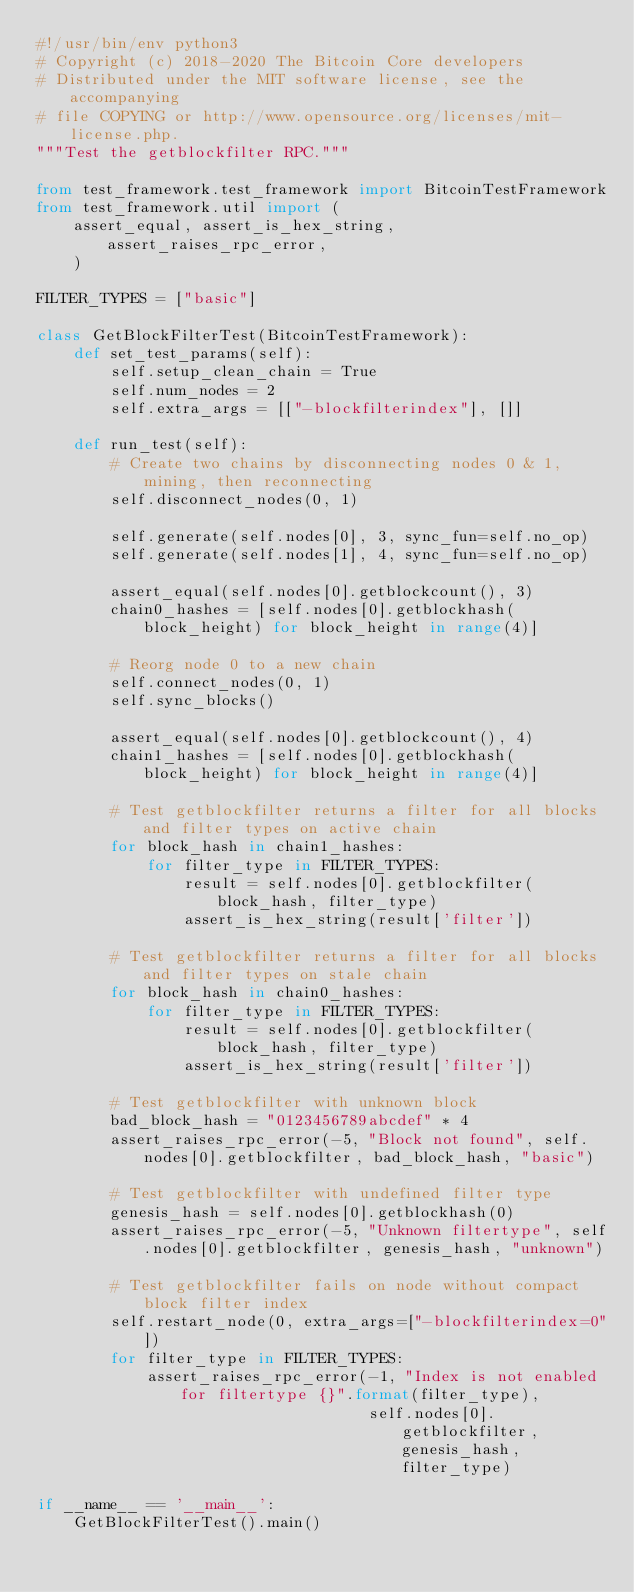<code> <loc_0><loc_0><loc_500><loc_500><_Python_>#!/usr/bin/env python3
# Copyright (c) 2018-2020 The Bitcoin Core developers
# Distributed under the MIT software license, see the accompanying
# file COPYING or http://www.opensource.org/licenses/mit-license.php.
"""Test the getblockfilter RPC."""

from test_framework.test_framework import BitcoinTestFramework
from test_framework.util import (
    assert_equal, assert_is_hex_string, assert_raises_rpc_error,
    )

FILTER_TYPES = ["basic"]

class GetBlockFilterTest(BitcoinTestFramework):
    def set_test_params(self):
        self.setup_clean_chain = True
        self.num_nodes = 2
        self.extra_args = [["-blockfilterindex"], []]

    def run_test(self):
        # Create two chains by disconnecting nodes 0 & 1, mining, then reconnecting
        self.disconnect_nodes(0, 1)

        self.generate(self.nodes[0], 3, sync_fun=self.no_op)
        self.generate(self.nodes[1], 4, sync_fun=self.no_op)

        assert_equal(self.nodes[0].getblockcount(), 3)
        chain0_hashes = [self.nodes[0].getblockhash(block_height) for block_height in range(4)]

        # Reorg node 0 to a new chain
        self.connect_nodes(0, 1)
        self.sync_blocks()

        assert_equal(self.nodes[0].getblockcount(), 4)
        chain1_hashes = [self.nodes[0].getblockhash(block_height) for block_height in range(4)]

        # Test getblockfilter returns a filter for all blocks and filter types on active chain
        for block_hash in chain1_hashes:
            for filter_type in FILTER_TYPES:
                result = self.nodes[0].getblockfilter(block_hash, filter_type)
                assert_is_hex_string(result['filter'])

        # Test getblockfilter returns a filter for all blocks and filter types on stale chain
        for block_hash in chain0_hashes:
            for filter_type in FILTER_TYPES:
                result = self.nodes[0].getblockfilter(block_hash, filter_type)
                assert_is_hex_string(result['filter'])

        # Test getblockfilter with unknown block
        bad_block_hash = "0123456789abcdef" * 4
        assert_raises_rpc_error(-5, "Block not found", self.nodes[0].getblockfilter, bad_block_hash, "basic")

        # Test getblockfilter with undefined filter type
        genesis_hash = self.nodes[0].getblockhash(0)
        assert_raises_rpc_error(-5, "Unknown filtertype", self.nodes[0].getblockfilter, genesis_hash, "unknown")

        # Test getblockfilter fails on node without compact block filter index
        self.restart_node(0, extra_args=["-blockfilterindex=0"])
        for filter_type in FILTER_TYPES:
            assert_raises_rpc_error(-1, "Index is not enabled for filtertype {}".format(filter_type),
                                    self.nodes[0].getblockfilter, genesis_hash, filter_type)

if __name__ == '__main__':
    GetBlockFilterTest().main()
</code> 